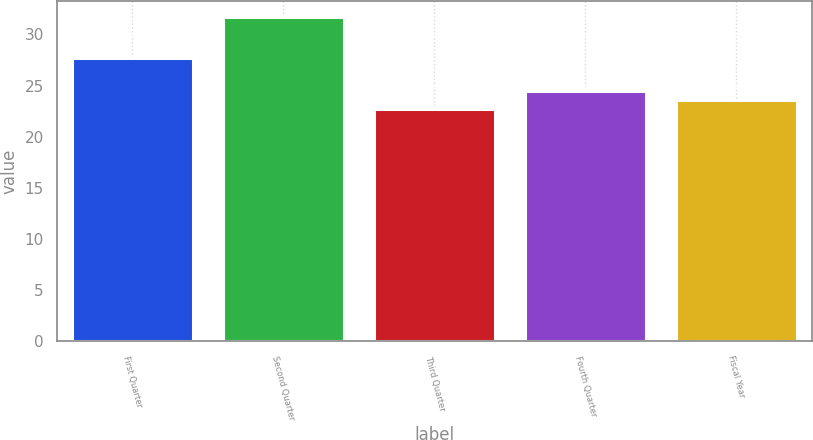Convert chart. <chart><loc_0><loc_0><loc_500><loc_500><bar_chart><fcel>First Quarter<fcel>Second Quarter<fcel>Third Quarter<fcel>Fourth Quarter<fcel>Fiscal Year<nl><fcel>27.72<fcel>31.68<fcel>22.69<fcel>24.49<fcel>23.59<nl></chart> 